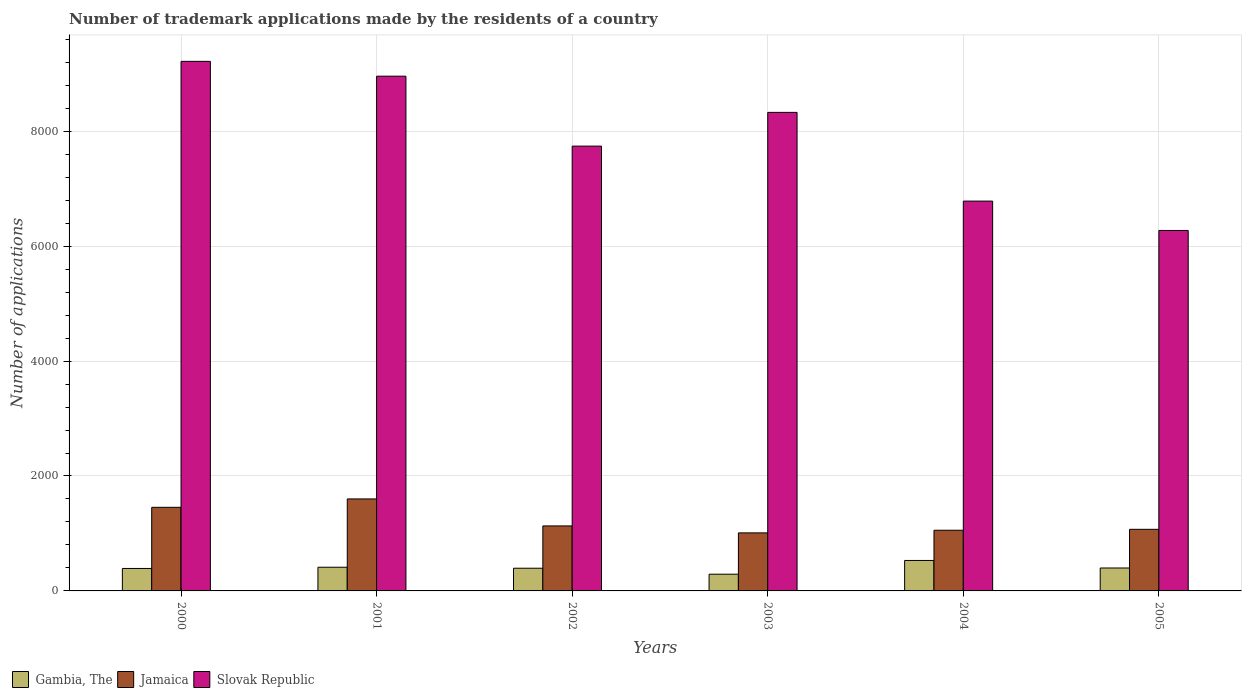How many different coloured bars are there?
Give a very brief answer. 3. How many groups of bars are there?
Make the answer very short. 6. How many bars are there on the 6th tick from the left?
Your answer should be very brief. 3. How many bars are there on the 1st tick from the right?
Make the answer very short. 3. What is the label of the 2nd group of bars from the left?
Your answer should be very brief. 2001. In how many cases, is the number of bars for a given year not equal to the number of legend labels?
Your answer should be compact. 0. What is the number of trademark applications made by the residents in Slovak Republic in 2005?
Your answer should be very brief. 6273. Across all years, what is the maximum number of trademark applications made by the residents in Gambia, The?
Provide a succinct answer. 530. Across all years, what is the minimum number of trademark applications made by the residents in Gambia, The?
Give a very brief answer. 291. In which year was the number of trademark applications made by the residents in Gambia, The minimum?
Provide a succinct answer. 2003. What is the total number of trademark applications made by the residents in Jamaica in the graph?
Offer a very short reply. 7325. What is the difference between the number of trademark applications made by the residents in Slovak Republic in 2003 and that in 2005?
Your answer should be very brief. 2055. What is the difference between the number of trademark applications made by the residents in Slovak Republic in 2005 and the number of trademark applications made by the residents in Gambia, The in 2002?
Offer a terse response. 5878. What is the average number of trademark applications made by the residents in Gambia, The per year?
Provide a short and direct response. 403. In the year 2003, what is the difference between the number of trademark applications made by the residents in Gambia, The and number of trademark applications made by the residents in Slovak Republic?
Your response must be concise. -8037. What is the ratio of the number of trademark applications made by the residents in Slovak Republic in 2003 to that in 2005?
Keep it short and to the point. 1.33. Is the number of trademark applications made by the residents in Slovak Republic in 2003 less than that in 2004?
Provide a succinct answer. No. Is the difference between the number of trademark applications made by the residents in Gambia, The in 2001 and 2005 greater than the difference between the number of trademark applications made by the residents in Slovak Republic in 2001 and 2005?
Your answer should be compact. No. What is the difference between the highest and the second highest number of trademark applications made by the residents in Gambia, The?
Provide a succinct answer. 118. What is the difference between the highest and the lowest number of trademark applications made by the residents in Jamaica?
Make the answer very short. 591. What does the 2nd bar from the left in 2000 represents?
Provide a short and direct response. Jamaica. What does the 3rd bar from the right in 2005 represents?
Your answer should be compact. Gambia, The. How many bars are there?
Your response must be concise. 18. Are all the bars in the graph horizontal?
Make the answer very short. No. How many years are there in the graph?
Keep it short and to the point. 6. What is the difference between two consecutive major ticks on the Y-axis?
Provide a short and direct response. 2000. Are the values on the major ticks of Y-axis written in scientific E-notation?
Your answer should be very brief. No. How are the legend labels stacked?
Provide a short and direct response. Horizontal. What is the title of the graph?
Offer a terse response. Number of trademark applications made by the residents of a country. What is the label or title of the X-axis?
Your answer should be very brief. Years. What is the label or title of the Y-axis?
Provide a short and direct response. Number of applications. What is the Number of applications of Gambia, The in 2000?
Provide a short and direct response. 391. What is the Number of applications of Jamaica in 2000?
Offer a terse response. 1455. What is the Number of applications of Slovak Republic in 2000?
Provide a succinct answer. 9216. What is the Number of applications in Gambia, The in 2001?
Your answer should be compact. 412. What is the Number of applications of Jamaica in 2001?
Make the answer very short. 1601. What is the Number of applications of Slovak Republic in 2001?
Your answer should be very brief. 8958. What is the Number of applications in Gambia, The in 2002?
Your answer should be compact. 395. What is the Number of applications in Jamaica in 2002?
Your answer should be compact. 1131. What is the Number of applications of Slovak Republic in 2002?
Your answer should be very brief. 7741. What is the Number of applications in Gambia, The in 2003?
Your answer should be compact. 291. What is the Number of applications of Jamaica in 2003?
Your answer should be very brief. 1010. What is the Number of applications of Slovak Republic in 2003?
Offer a very short reply. 8328. What is the Number of applications in Gambia, The in 2004?
Provide a succinct answer. 530. What is the Number of applications of Jamaica in 2004?
Make the answer very short. 1056. What is the Number of applications of Slovak Republic in 2004?
Your answer should be compact. 6784. What is the Number of applications of Gambia, The in 2005?
Keep it short and to the point. 399. What is the Number of applications of Jamaica in 2005?
Give a very brief answer. 1072. What is the Number of applications of Slovak Republic in 2005?
Give a very brief answer. 6273. Across all years, what is the maximum Number of applications in Gambia, The?
Make the answer very short. 530. Across all years, what is the maximum Number of applications of Jamaica?
Provide a short and direct response. 1601. Across all years, what is the maximum Number of applications of Slovak Republic?
Give a very brief answer. 9216. Across all years, what is the minimum Number of applications of Gambia, The?
Your answer should be very brief. 291. Across all years, what is the minimum Number of applications in Jamaica?
Offer a very short reply. 1010. Across all years, what is the minimum Number of applications in Slovak Republic?
Offer a very short reply. 6273. What is the total Number of applications of Gambia, The in the graph?
Give a very brief answer. 2418. What is the total Number of applications in Jamaica in the graph?
Provide a succinct answer. 7325. What is the total Number of applications in Slovak Republic in the graph?
Offer a very short reply. 4.73e+04. What is the difference between the Number of applications in Jamaica in 2000 and that in 2001?
Offer a very short reply. -146. What is the difference between the Number of applications of Slovak Republic in 2000 and that in 2001?
Provide a short and direct response. 258. What is the difference between the Number of applications of Gambia, The in 2000 and that in 2002?
Offer a very short reply. -4. What is the difference between the Number of applications of Jamaica in 2000 and that in 2002?
Your response must be concise. 324. What is the difference between the Number of applications of Slovak Republic in 2000 and that in 2002?
Make the answer very short. 1475. What is the difference between the Number of applications in Jamaica in 2000 and that in 2003?
Provide a short and direct response. 445. What is the difference between the Number of applications in Slovak Republic in 2000 and that in 2003?
Give a very brief answer. 888. What is the difference between the Number of applications in Gambia, The in 2000 and that in 2004?
Offer a terse response. -139. What is the difference between the Number of applications in Jamaica in 2000 and that in 2004?
Your answer should be very brief. 399. What is the difference between the Number of applications in Slovak Republic in 2000 and that in 2004?
Provide a succinct answer. 2432. What is the difference between the Number of applications of Gambia, The in 2000 and that in 2005?
Offer a very short reply. -8. What is the difference between the Number of applications in Jamaica in 2000 and that in 2005?
Your response must be concise. 383. What is the difference between the Number of applications in Slovak Republic in 2000 and that in 2005?
Provide a short and direct response. 2943. What is the difference between the Number of applications in Gambia, The in 2001 and that in 2002?
Provide a succinct answer. 17. What is the difference between the Number of applications in Jamaica in 2001 and that in 2002?
Your answer should be compact. 470. What is the difference between the Number of applications in Slovak Republic in 2001 and that in 2002?
Provide a succinct answer. 1217. What is the difference between the Number of applications in Gambia, The in 2001 and that in 2003?
Provide a succinct answer. 121. What is the difference between the Number of applications in Jamaica in 2001 and that in 2003?
Provide a succinct answer. 591. What is the difference between the Number of applications of Slovak Republic in 2001 and that in 2003?
Provide a short and direct response. 630. What is the difference between the Number of applications of Gambia, The in 2001 and that in 2004?
Your answer should be very brief. -118. What is the difference between the Number of applications of Jamaica in 2001 and that in 2004?
Your answer should be very brief. 545. What is the difference between the Number of applications of Slovak Republic in 2001 and that in 2004?
Provide a succinct answer. 2174. What is the difference between the Number of applications of Gambia, The in 2001 and that in 2005?
Offer a terse response. 13. What is the difference between the Number of applications of Jamaica in 2001 and that in 2005?
Give a very brief answer. 529. What is the difference between the Number of applications of Slovak Republic in 2001 and that in 2005?
Your answer should be compact. 2685. What is the difference between the Number of applications in Gambia, The in 2002 and that in 2003?
Provide a succinct answer. 104. What is the difference between the Number of applications in Jamaica in 2002 and that in 2003?
Ensure brevity in your answer.  121. What is the difference between the Number of applications of Slovak Republic in 2002 and that in 2003?
Make the answer very short. -587. What is the difference between the Number of applications of Gambia, The in 2002 and that in 2004?
Your answer should be very brief. -135. What is the difference between the Number of applications of Slovak Republic in 2002 and that in 2004?
Your answer should be very brief. 957. What is the difference between the Number of applications of Gambia, The in 2002 and that in 2005?
Provide a short and direct response. -4. What is the difference between the Number of applications in Slovak Republic in 2002 and that in 2005?
Your response must be concise. 1468. What is the difference between the Number of applications in Gambia, The in 2003 and that in 2004?
Provide a succinct answer. -239. What is the difference between the Number of applications of Jamaica in 2003 and that in 2004?
Keep it short and to the point. -46. What is the difference between the Number of applications of Slovak Republic in 2003 and that in 2004?
Your answer should be very brief. 1544. What is the difference between the Number of applications of Gambia, The in 2003 and that in 2005?
Provide a short and direct response. -108. What is the difference between the Number of applications in Jamaica in 2003 and that in 2005?
Make the answer very short. -62. What is the difference between the Number of applications in Slovak Republic in 2003 and that in 2005?
Give a very brief answer. 2055. What is the difference between the Number of applications in Gambia, The in 2004 and that in 2005?
Provide a succinct answer. 131. What is the difference between the Number of applications of Jamaica in 2004 and that in 2005?
Offer a very short reply. -16. What is the difference between the Number of applications in Slovak Republic in 2004 and that in 2005?
Provide a short and direct response. 511. What is the difference between the Number of applications in Gambia, The in 2000 and the Number of applications in Jamaica in 2001?
Your answer should be very brief. -1210. What is the difference between the Number of applications in Gambia, The in 2000 and the Number of applications in Slovak Republic in 2001?
Make the answer very short. -8567. What is the difference between the Number of applications in Jamaica in 2000 and the Number of applications in Slovak Republic in 2001?
Provide a succinct answer. -7503. What is the difference between the Number of applications in Gambia, The in 2000 and the Number of applications in Jamaica in 2002?
Give a very brief answer. -740. What is the difference between the Number of applications of Gambia, The in 2000 and the Number of applications of Slovak Republic in 2002?
Ensure brevity in your answer.  -7350. What is the difference between the Number of applications in Jamaica in 2000 and the Number of applications in Slovak Republic in 2002?
Offer a terse response. -6286. What is the difference between the Number of applications in Gambia, The in 2000 and the Number of applications in Jamaica in 2003?
Provide a succinct answer. -619. What is the difference between the Number of applications of Gambia, The in 2000 and the Number of applications of Slovak Republic in 2003?
Make the answer very short. -7937. What is the difference between the Number of applications in Jamaica in 2000 and the Number of applications in Slovak Republic in 2003?
Provide a succinct answer. -6873. What is the difference between the Number of applications of Gambia, The in 2000 and the Number of applications of Jamaica in 2004?
Offer a very short reply. -665. What is the difference between the Number of applications in Gambia, The in 2000 and the Number of applications in Slovak Republic in 2004?
Your answer should be very brief. -6393. What is the difference between the Number of applications of Jamaica in 2000 and the Number of applications of Slovak Republic in 2004?
Give a very brief answer. -5329. What is the difference between the Number of applications of Gambia, The in 2000 and the Number of applications of Jamaica in 2005?
Make the answer very short. -681. What is the difference between the Number of applications in Gambia, The in 2000 and the Number of applications in Slovak Republic in 2005?
Provide a succinct answer. -5882. What is the difference between the Number of applications in Jamaica in 2000 and the Number of applications in Slovak Republic in 2005?
Offer a very short reply. -4818. What is the difference between the Number of applications of Gambia, The in 2001 and the Number of applications of Jamaica in 2002?
Keep it short and to the point. -719. What is the difference between the Number of applications of Gambia, The in 2001 and the Number of applications of Slovak Republic in 2002?
Provide a succinct answer. -7329. What is the difference between the Number of applications in Jamaica in 2001 and the Number of applications in Slovak Republic in 2002?
Keep it short and to the point. -6140. What is the difference between the Number of applications of Gambia, The in 2001 and the Number of applications of Jamaica in 2003?
Give a very brief answer. -598. What is the difference between the Number of applications of Gambia, The in 2001 and the Number of applications of Slovak Republic in 2003?
Your answer should be compact. -7916. What is the difference between the Number of applications in Jamaica in 2001 and the Number of applications in Slovak Republic in 2003?
Keep it short and to the point. -6727. What is the difference between the Number of applications of Gambia, The in 2001 and the Number of applications of Jamaica in 2004?
Offer a terse response. -644. What is the difference between the Number of applications in Gambia, The in 2001 and the Number of applications in Slovak Republic in 2004?
Your answer should be very brief. -6372. What is the difference between the Number of applications in Jamaica in 2001 and the Number of applications in Slovak Republic in 2004?
Give a very brief answer. -5183. What is the difference between the Number of applications in Gambia, The in 2001 and the Number of applications in Jamaica in 2005?
Make the answer very short. -660. What is the difference between the Number of applications of Gambia, The in 2001 and the Number of applications of Slovak Republic in 2005?
Your answer should be very brief. -5861. What is the difference between the Number of applications in Jamaica in 2001 and the Number of applications in Slovak Republic in 2005?
Offer a very short reply. -4672. What is the difference between the Number of applications in Gambia, The in 2002 and the Number of applications in Jamaica in 2003?
Provide a short and direct response. -615. What is the difference between the Number of applications in Gambia, The in 2002 and the Number of applications in Slovak Republic in 2003?
Your answer should be very brief. -7933. What is the difference between the Number of applications in Jamaica in 2002 and the Number of applications in Slovak Republic in 2003?
Make the answer very short. -7197. What is the difference between the Number of applications in Gambia, The in 2002 and the Number of applications in Jamaica in 2004?
Your answer should be very brief. -661. What is the difference between the Number of applications in Gambia, The in 2002 and the Number of applications in Slovak Republic in 2004?
Your answer should be compact. -6389. What is the difference between the Number of applications of Jamaica in 2002 and the Number of applications of Slovak Republic in 2004?
Your answer should be compact. -5653. What is the difference between the Number of applications of Gambia, The in 2002 and the Number of applications of Jamaica in 2005?
Provide a short and direct response. -677. What is the difference between the Number of applications of Gambia, The in 2002 and the Number of applications of Slovak Republic in 2005?
Make the answer very short. -5878. What is the difference between the Number of applications of Jamaica in 2002 and the Number of applications of Slovak Republic in 2005?
Your answer should be compact. -5142. What is the difference between the Number of applications of Gambia, The in 2003 and the Number of applications of Jamaica in 2004?
Make the answer very short. -765. What is the difference between the Number of applications of Gambia, The in 2003 and the Number of applications of Slovak Republic in 2004?
Give a very brief answer. -6493. What is the difference between the Number of applications in Jamaica in 2003 and the Number of applications in Slovak Republic in 2004?
Provide a succinct answer. -5774. What is the difference between the Number of applications of Gambia, The in 2003 and the Number of applications of Jamaica in 2005?
Your answer should be very brief. -781. What is the difference between the Number of applications in Gambia, The in 2003 and the Number of applications in Slovak Republic in 2005?
Your response must be concise. -5982. What is the difference between the Number of applications of Jamaica in 2003 and the Number of applications of Slovak Republic in 2005?
Your answer should be compact. -5263. What is the difference between the Number of applications in Gambia, The in 2004 and the Number of applications in Jamaica in 2005?
Your answer should be compact. -542. What is the difference between the Number of applications in Gambia, The in 2004 and the Number of applications in Slovak Republic in 2005?
Ensure brevity in your answer.  -5743. What is the difference between the Number of applications of Jamaica in 2004 and the Number of applications of Slovak Republic in 2005?
Your answer should be very brief. -5217. What is the average Number of applications in Gambia, The per year?
Provide a short and direct response. 403. What is the average Number of applications in Jamaica per year?
Offer a terse response. 1220.83. What is the average Number of applications of Slovak Republic per year?
Provide a succinct answer. 7883.33. In the year 2000, what is the difference between the Number of applications in Gambia, The and Number of applications in Jamaica?
Your response must be concise. -1064. In the year 2000, what is the difference between the Number of applications of Gambia, The and Number of applications of Slovak Republic?
Offer a very short reply. -8825. In the year 2000, what is the difference between the Number of applications of Jamaica and Number of applications of Slovak Republic?
Provide a short and direct response. -7761. In the year 2001, what is the difference between the Number of applications of Gambia, The and Number of applications of Jamaica?
Make the answer very short. -1189. In the year 2001, what is the difference between the Number of applications in Gambia, The and Number of applications in Slovak Republic?
Offer a terse response. -8546. In the year 2001, what is the difference between the Number of applications of Jamaica and Number of applications of Slovak Republic?
Keep it short and to the point. -7357. In the year 2002, what is the difference between the Number of applications in Gambia, The and Number of applications in Jamaica?
Keep it short and to the point. -736. In the year 2002, what is the difference between the Number of applications in Gambia, The and Number of applications in Slovak Republic?
Offer a very short reply. -7346. In the year 2002, what is the difference between the Number of applications in Jamaica and Number of applications in Slovak Republic?
Keep it short and to the point. -6610. In the year 2003, what is the difference between the Number of applications in Gambia, The and Number of applications in Jamaica?
Ensure brevity in your answer.  -719. In the year 2003, what is the difference between the Number of applications in Gambia, The and Number of applications in Slovak Republic?
Ensure brevity in your answer.  -8037. In the year 2003, what is the difference between the Number of applications in Jamaica and Number of applications in Slovak Republic?
Provide a succinct answer. -7318. In the year 2004, what is the difference between the Number of applications in Gambia, The and Number of applications in Jamaica?
Make the answer very short. -526. In the year 2004, what is the difference between the Number of applications of Gambia, The and Number of applications of Slovak Republic?
Offer a very short reply. -6254. In the year 2004, what is the difference between the Number of applications in Jamaica and Number of applications in Slovak Republic?
Make the answer very short. -5728. In the year 2005, what is the difference between the Number of applications of Gambia, The and Number of applications of Jamaica?
Your answer should be very brief. -673. In the year 2005, what is the difference between the Number of applications of Gambia, The and Number of applications of Slovak Republic?
Your answer should be very brief. -5874. In the year 2005, what is the difference between the Number of applications of Jamaica and Number of applications of Slovak Republic?
Keep it short and to the point. -5201. What is the ratio of the Number of applications in Gambia, The in 2000 to that in 2001?
Offer a terse response. 0.95. What is the ratio of the Number of applications in Jamaica in 2000 to that in 2001?
Offer a terse response. 0.91. What is the ratio of the Number of applications in Slovak Republic in 2000 to that in 2001?
Ensure brevity in your answer.  1.03. What is the ratio of the Number of applications of Gambia, The in 2000 to that in 2002?
Your answer should be very brief. 0.99. What is the ratio of the Number of applications of Jamaica in 2000 to that in 2002?
Your answer should be very brief. 1.29. What is the ratio of the Number of applications of Slovak Republic in 2000 to that in 2002?
Offer a very short reply. 1.19. What is the ratio of the Number of applications of Gambia, The in 2000 to that in 2003?
Offer a very short reply. 1.34. What is the ratio of the Number of applications of Jamaica in 2000 to that in 2003?
Provide a short and direct response. 1.44. What is the ratio of the Number of applications of Slovak Republic in 2000 to that in 2003?
Make the answer very short. 1.11. What is the ratio of the Number of applications in Gambia, The in 2000 to that in 2004?
Keep it short and to the point. 0.74. What is the ratio of the Number of applications in Jamaica in 2000 to that in 2004?
Make the answer very short. 1.38. What is the ratio of the Number of applications of Slovak Republic in 2000 to that in 2004?
Offer a terse response. 1.36. What is the ratio of the Number of applications of Gambia, The in 2000 to that in 2005?
Your answer should be compact. 0.98. What is the ratio of the Number of applications of Jamaica in 2000 to that in 2005?
Make the answer very short. 1.36. What is the ratio of the Number of applications in Slovak Republic in 2000 to that in 2005?
Your response must be concise. 1.47. What is the ratio of the Number of applications of Gambia, The in 2001 to that in 2002?
Your answer should be very brief. 1.04. What is the ratio of the Number of applications of Jamaica in 2001 to that in 2002?
Make the answer very short. 1.42. What is the ratio of the Number of applications in Slovak Republic in 2001 to that in 2002?
Your answer should be very brief. 1.16. What is the ratio of the Number of applications of Gambia, The in 2001 to that in 2003?
Ensure brevity in your answer.  1.42. What is the ratio of the Number of applications of Jamaica in 2001 to that in 2003?
Keep it short and to the point. 1.59. What is the ratio of the Number of applications of Slovak Republic in 2001 to that in 2003?
Your response must be concise. 1.08. What is the ratio of the Number of applications of Gambia, The in 2001 to that in 2004?
Provide a short and direct response. 0.78. What is the ratio of the Number of applications in Jamaica in 2001 to that in 2004?
Your response must be concise. 1.52. What is the ratio of the Number of applications of Slovak Republic in 2001 to that in 2004?
Your answer should be very brief. 1.32. What is the ratio of the Number of applications of Gambia, The in 2001 to that in 2005?
Offer a very short reply. 1.03. What is the ratio of the Number of applications in Jamaica in 2001 to that in 2005?
Your answer should be compact. 1.49. What is the ratio of the Number of applications of Slovak Republic in 2001 to that in 2005?
Give a very brief answer. 1.43. What is the ratio of the Number of applications in Gambia, The in 2002 to that in 2003?
Provide a succinct answer. 1.36. What is the ratio of the Number of applications in Jamaica in 2002 to that in 2003?
Your answer should be compact. 1.12. What is the ratio of the Number of applications in Slovak Republic in 2002 to that in 2003?
Provide a succinct answer. 0.93. What is the ratio of the Number of applications in Gambia, The in 2002 to that in 2004?
Make the answer very short. 0.75. What is the ratio of the Number of applications of Jamaica in 2002 to that in 2004?
Make the answer very short. 1.07. What is the ratio of the Number of applications of Slovak Republic in 2002 to that in 2004?
Your answer should be compact. 1.14. What is the ratio of the Number of applications of Gambia, The in 2002 to that in 2005?
Provide a short and direct response. 0.99. What is the ratio of the Number of applications in Jamaica in 2002 to that in 2005?
Provide a short and direct response. 1.05. What is the ratio of the Number of applications in Slovak Republic in 2002 to that in 2005?
Ensure brevity in your answer.  1.23. What is the ratio of the Number of applications of Gambia, The in 2003 to that in 2004?
Give a very brief answer. 0.55. What is the ratio of the Number of applications in Jamaica in 2003 to that in 2004?
Offer a terse response. 0.96. What is the ratio of the Number of applications of Slovak Republic in 2003 to that in 2004?
Ensure brevity in your answer.  1.23. What is the ratio of the Number of applications in Gambia, The in 2003 to that in 2005?
Your answer should be very brief. 0.73. What is the ratio of the Number of applications in Jamaica in 2003 to that in 2005?
Your response must be concise. 0.94. What is the ratio of the Number of applications of Slovak Republic in 2003 to that in 2005?
Your response must be concise. 1.33. What is the ratio of the Number of applications in Gambia, The in 2004 to that in 2005?
Offer a terse response. 1.33. What is the ratio of the Number of applications in Jamaica in 2004 to that in 2005?
Offer a very short reply. 0.99. What is the ratio of the Number of applications of Slovak Republic in 2004 to that in 2005?
Provide a short and direct response. 1.08. What is the difference between the highest and the second highest Number of applications in Gambia, The?
Keep it short and to the point. 118. What is the difference between the highest and the second highest Number of applications in Jamaica?
Offer a very short reply. 146. What is the difference between the highest and the second highest Number of applications of Slovak Republic?
Your response must be concise. 258. What is the difference between the highest and the lowest Number of applications in Gambia, The?
Make the answer very short. 239. What is the difference between the highest and the lowest Number of applications of Jamaica?
Your answer should be very brief. 591. What is the difference between the highest and the lowest Number of applications in Slovak Republic?
Provide a succinct answer. 2943. 